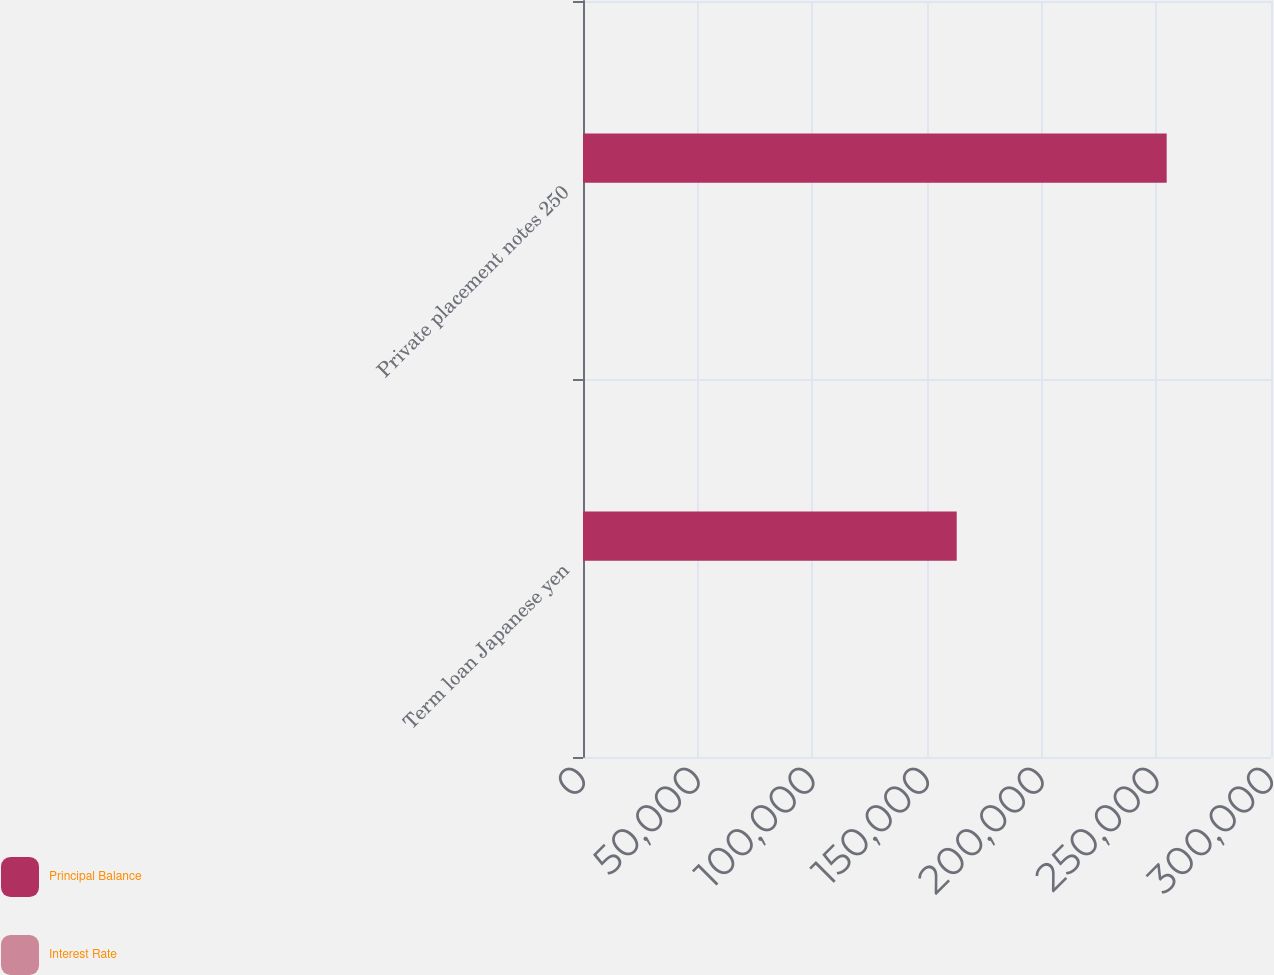<chart> <loc_0><loc_0><loc_500><loc_500><stacked_bar_chart><ecel><fcel>Term loan Japanese yen<fcel>Private placement notes 250<nl><fcel>Principal Balance<fcel>162956<fcel>254512<nl><fcel>Interest Rate<fcel>1.1<fcel>4.1<nl></chart> 